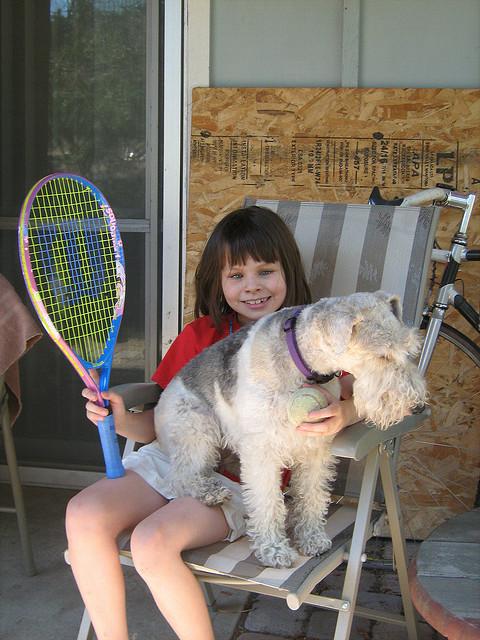What is the girl holding?
Short answer required. Dog. How many dogs?
Be succinct. 1. What color is the dog?
Give a very brief answer. White and gray. 